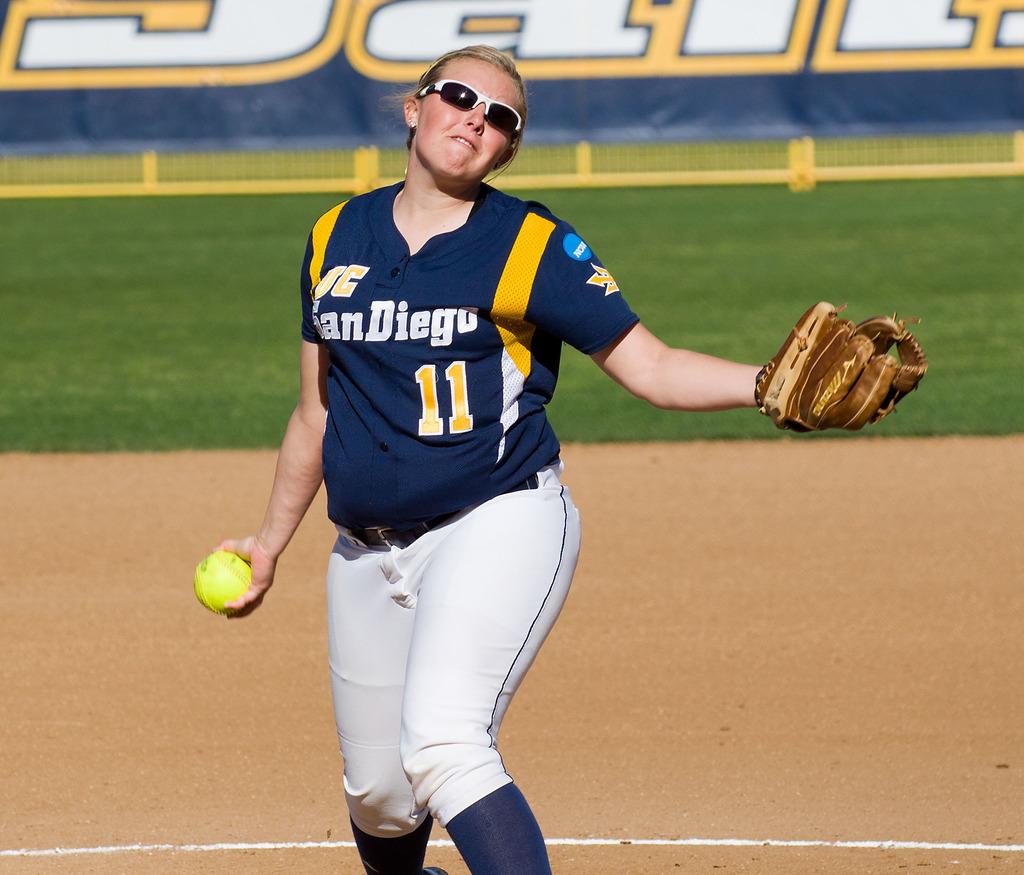What is her player number?
Your answer should be very brief. 11. 